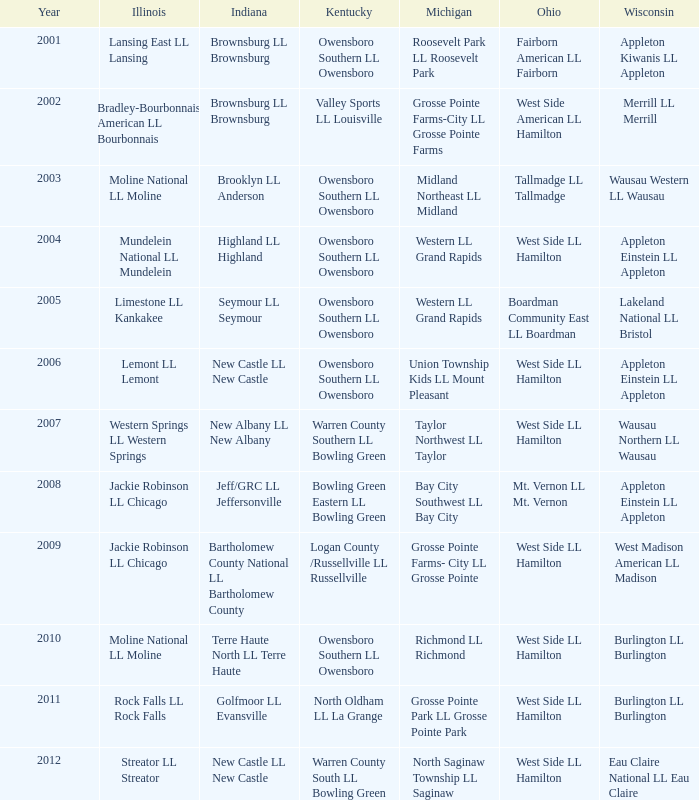What was the little league team from Kentucky when the little league team from Indiana and Wisconsin were Brownsburg LL Brownsburg and Merrill LL Merrill? Valley Sports LL Louisville. 